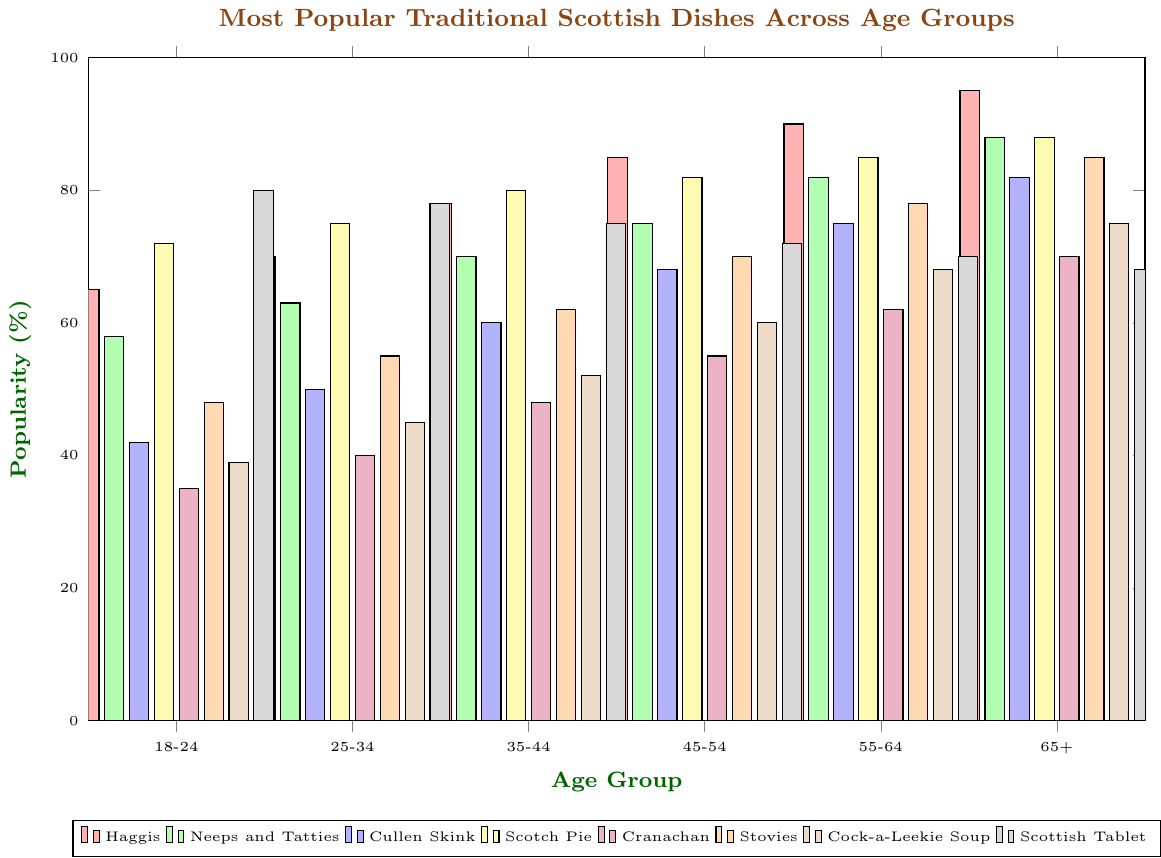What is the most popular dish among the 18-24 age group? The most popular dish among the 18-24 age group can be identified by the highest bar in the 18-24 category. The dish "Scottish Tablet" has the highest percentage at 80%.
Answer: Scottish Tablet Which age group enjoys Haggis the most? We look for the age group with the tallest bar for Haggis. The bar for the 65+ age group is the highest at 95%.
Answer: 65+ By how much does the popularity of Cranachan increase from the 18-24 group to the 65+ group? The popularity among the 18-24 age group is 35, and it increases to 70 in the 65+ group. The difference is calculated as 70 - 35 = 35.
Answer: 35 What is the average popularity of Stovies across all age groups? The popularity values for Stovies are {48, 55, 62, 70, 78, 85}. The sum is 398, and there are 6 age groups, so the average is 398 / 6 = 66.33.
Answer: 66.33 Compare the popularity of Cullen Skink between the 25-34 and 65+ age groups. Cullen Skink is 50% popular among the 25-34 group and 82% in the 65+ group. Cullen Skink's popularity among the 65+ age group is higher.
Answer: The 65+ group prefers it more What proportion of the age groups prefers Neeps and Tatties over Haggis? Neeps and Tatties are popular percentages {58, 63, 70, 75, 82, 88}, while Haggis are {65, 70, 78, 85, 90, 95}. In none of the age groups is Neeps and Tatties percentage greater than Haggis.
Answer: 0% Which age group has the smallest difference in popularity between Scotch Pie and Scottish Tablet? Calculate the absolute differences for each group: 18-24 (72 - 80 = 8), 25-34 (75 - 78 = 3), 35-44 (80 - 75 = 5), 45-54 (82 - 72 = 10), 55-64 (85 - 70 = 15), 65+ (88 - 68 = 20). The smallest difference is for the 25-34 group (3).
Answer: 25-34 What is the trend in popularity for Cock-a-Leekie Soup across age groups? Looking at the heights of the bars, its popularity increases steadily as the age group increases from 18-24 (39) to 65+ (75). This shows an increasing trend.
Answer: Increasing 